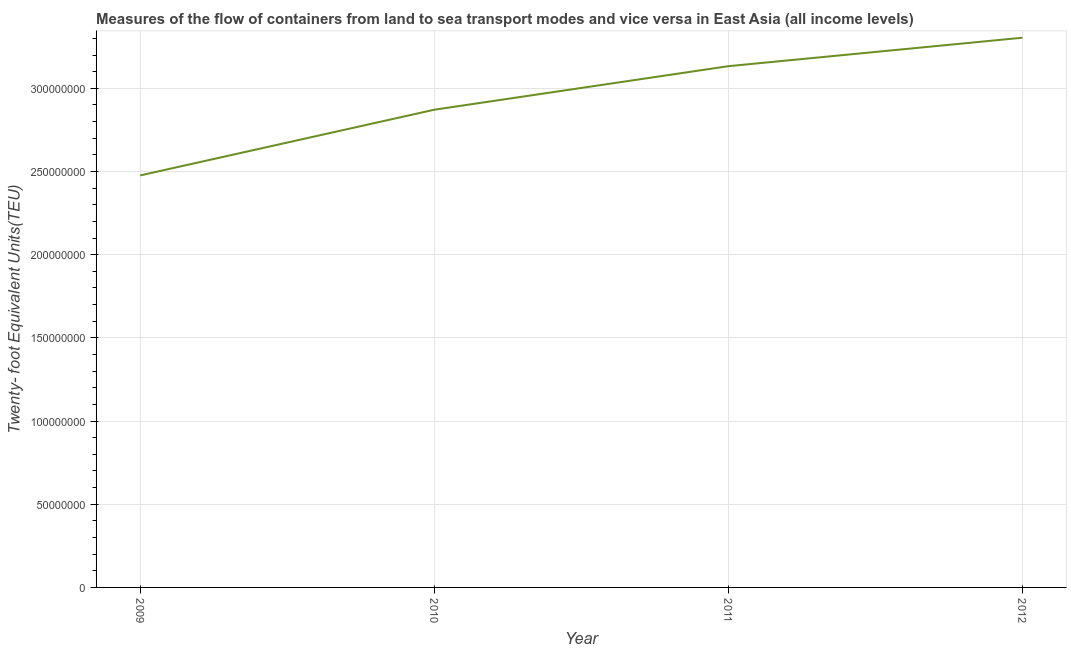What is the container port traffic in 2010?
Your answer should be compact. 2.87e+08. Across all years, what is the maximum container port traffic?
Keep it short and to the point. 3.30e+08. Across all years, what is the minimum container port traffic?
Make the answer very short. 2.48e+08. In which year was the container port traffic minimum?
Give a very brief answer. 2009. What is the sum of the container port traffic?
Your response must be concise. 1.18e+09. What is the difference between the container port traffic in 2011 and 2012?
Give a very brief answer. -1.71e+07. What is the average container port traffic per year?
Offer a very short reply. 2.95e+08. What is the median container port traffic?
Offer a terse response. 3.00e+08. Do a majority of the years between 2011 and 2012 (inclusive) have container port traffic greater than 90000000 TEU?
Provide a short and direct response. Yes. What is the ratio of the container port traffic in 2009 to that in 2010?
Your answer should be compact. 0.86. Is the container port traffic in 2009 less than that in 2010?
Provide a short and direct response. Yes. Is the difference between the container port traffic in 2011 and 2012 greater than the difference between any two years?
Give a very brief answer. No. What is the difference between the highest and the second highest container port traffic?
Offer a terse response. 1.71e+07. Is the sum of the container port traffic in 2009 and 2011 greater than the maximum container port traffic across all years?
Provide a short and direct response. Yes. What is the difference between the highest and the lowest container port traffic?
Make the answer very short. 8.28e+07. Does the container port traffic monotonically increase over the years?
Offer a very short reply. Yes. How many lines are there?
Provide a short and direct response. 1. How many years are there in the graph?
Make the answer very short. 4. What is the difference between two consecutive major ticks on the Y-axis?
Offer a terse response. 5.00e+07. Does the graph contain any zero values?
Offer a very short reply. No. What is the title of the graph?
Give a very brief answer. Measures of the flow of containers from land to sea transport modes and vice versa in East Asia (all income levels). What is the label or title of the Y-axis?
Give a very brief answer. Twenty- foot Equivalent Units(TEU). What is the Twenty- foot Equivalent Units(TEU) of 2009?
Provide a short and direct response. 2.48e+08. What is the Twenty- foot Equivalent Units(TEU) of 2010?
Give a very brief answer. 2.87e+08. What is the Twenty- foot Equivalent Units(TEU) in 2011?
Provide a short and direct response. 3.13e+08. What is the Twenty- foot Equivalent Units(TEU) in 2012?
Offer a very short reply. 3.30e+08. What is the difference between the Twenty- foot Equivalent Units(TEU) in 2009 and 2010?
Your response must be concise. -3.95e+07. What is the difference between the Twenty- foot Equivalent Units(TEU) in 2009 and 2011?
Ensure brevity in your answer.  -6.57e+07. What is the difference between the Twenty- foot Equivalent Units(TEU) in 2009 and 2012?
Your answer should be very brief. -8.28e+07. What is the difference between the Twenty- foot Equivalent Units(TEU) in 2010 and 2011?
Your response must be concise. -2.62e+07. What is the difference between the Twenty- foot Equivalent Units(TEU) in 2010 and 2012?
Ensure brevity in your answer.  -4.33e+07. What is the difference between the Twenty- foot Equivalent Units(TEU) in 2011 and 2012?
Your answer should be compact. -1.71e+07. What is the ratio of the Twenty- foot Equivalent Units(TEU) in 2009 to that in 2010?
Provide a short and direct response. 0.86. What is the ratio of the Twenty- foot Equivalent Units(TEU) in 2009 to that in 2011?
Your answer should be very brief. 0.79. What is the ratio of the Twenty- foot Equivalent Units(TEU) in 2010 to that in 2011?
Make the answer very short. 0.92. What is the ratio of the Twenty- foot Equivalent Units(TEU) in 2010 to that in 2012?
Make the answer very short. 0.87. What is the ratio of the Twenty- foot Equivalent Units(TEU) in 2011 to that in 2012?
Your answer should be very brief. 0.95. 